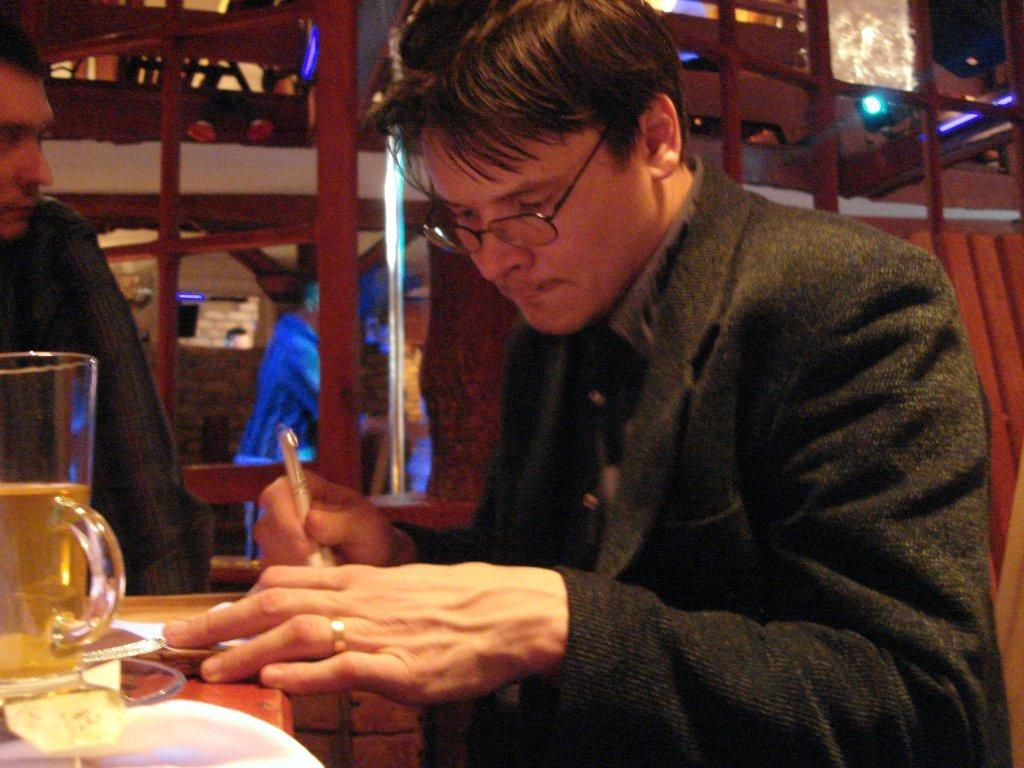How many people are in the image? There are two persons in the image. What is the person on the left wearing? The person on the left is wearing spectacles. What is the person with spectacles holding? The person with spectacles is holding a pen. What object is on a platform in the image? There is a glass on a platform in the image. Can you describe the background of the image? There is a person, a wall, and lights in the background of the image. What type of house can be seen in the background of the image? There is no house present in the background of the image; it features a person, a wall, and lights. How many ducks are visible in the image? There are no ducks present in the image. 